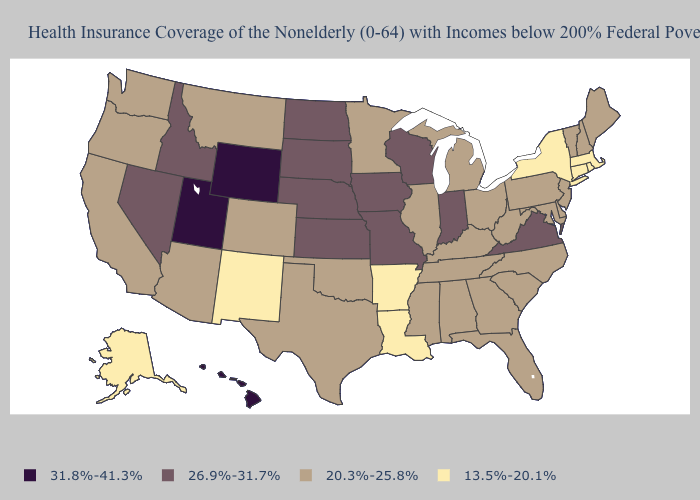Among the states that border North Dakota , does Montana have the highest value?
Be succinct. No. What is the lowest value in the USA?
Be succinct. 13.5%-20.1%. What is the value of Louisiana?
Concise answer only. 13.5%-20.1%. What is the value of South Dakota?
Quick response, please. 26.9%-31.7%. Which states have the lowest value in the MidWest?
Write a very short answer. Illinois, Michigan, Minnesota, Ohio. Name the states that have a value in the range 13.5%-20.1%?
Give a very brief answer. Alaska, Arkansas, Connecticut, Louisiana, Massachusetts, New Mexico, New York, Rhode Island. Does Utah have the same value as Hawaii?
Be succinct. Yes. Does Connecticut have the lowest value in the USA?
Concise answer only. Yes. Which states have the lowest value in the South?
Quick response, please. Arkansas, Louisiana. What is the value of Texas?
Be succinct. 20.3%-25.8%. What is the value of Missouri?
Be succinct. 26.9%-31.7%. What is the value of Louisiana?
Give a very brief answer. 13.5%-20.1%. What is the highest value in states that border Maine?
Quick response, please. 20.3%-25.8%. Does Nebraska have a higher value than Massachusetts?
Short answer required. Yes. Name the states that have a value in the range 20.3%-25.8%?
Short answer required. Alabama, Arizona, California, Colorado, Delaware, Florida, Georgia, Illinois, Kentucky, Maine, Maryland, Michigan, Minnesota, Mississippi, Montana, New Hampshire, New Jersey, North Carolina, Ohio, Oklahoma, Oregon, Pennsylvania, South Carolina, Tennessee, Texas, Vermont, Washington, West Virginia. 